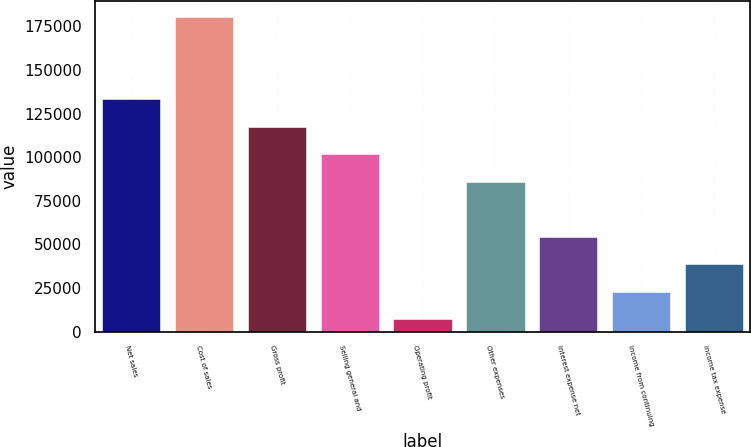<chart> <loc_0><loc_0><loc_500><loc_500><bar_chart><fcel>Net sales<fcel>Cost of sales<fcel>Gross profit<fcel>Selling general and<fcel>Operating profit<fcel>Other expenses<fcel>Interest expense net<fcel>Income from continuing<fcel>Income tax expense<nl><fcel>133075<fcel>180349<fcel>117317<fcel>101559<fcel>7012<fcel>85801.5<fcel>54285.7<fcel>22769.9<fcel>38527.8<nl></chart> 